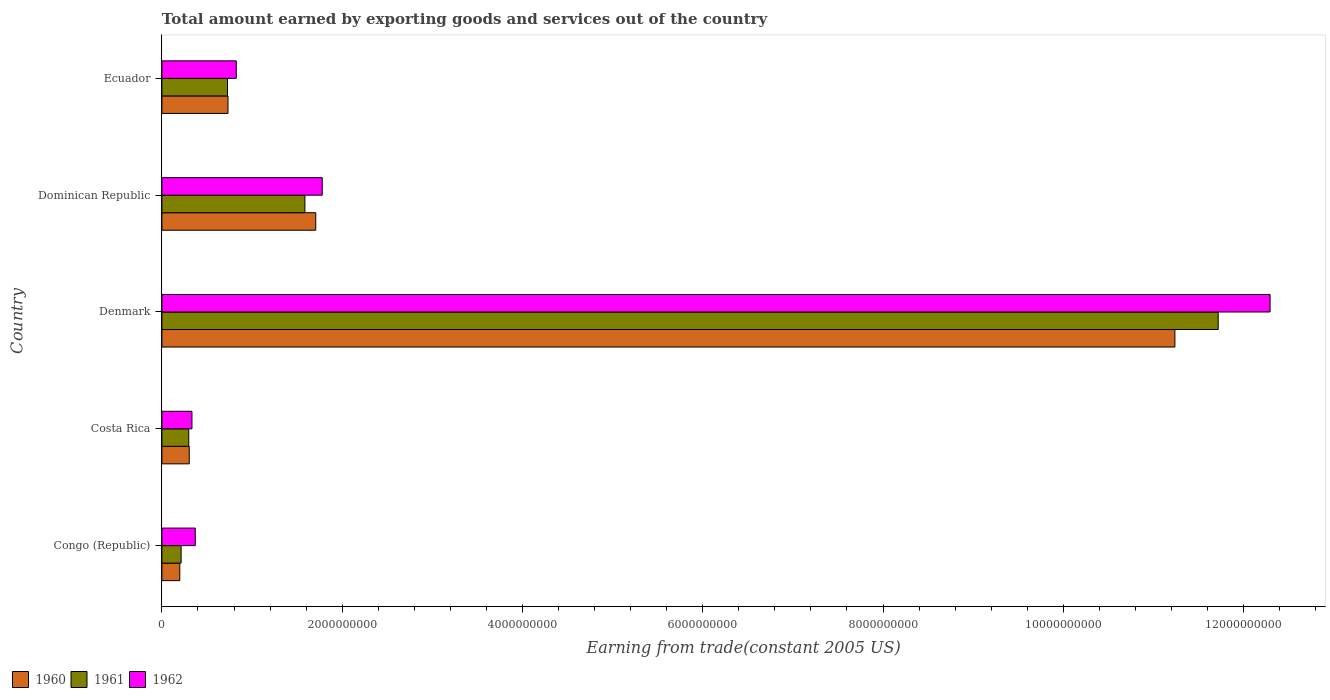How many groups of bars are there?
Provide a succinct answer. 5. What is the label of the 3rd group of bars from the top?
Ensure brevity in your answer.  Denmark. What is the total amount earned by exporting goods and services in 1961 in Denmark?
Give a very brief answer. 1.17e+1. Across all countries, what is the maximum total amount earned by exporting goods and services in 1960?
Offer a terse response. 1.12e+1. Across all countries, what is the minimum total amount earned by exporting goods and services in 1962?
Provide a succinct answer. 3.33e+08. In which country was the total amount earned by exporting goods and services in 1960 maximum?
Offer a very short reply. Denmark. In which country was the total amount earned by exporting goods and services in 1961 minimum?
Offer a terse response. Congo (Republic). What is the total total amount earned by exporting goods and services in 1962 in the graph?
Your answer should be very brief. 1.56e+1. What is the difference between the total amount earned by exporting goods and services in 1961 in Denmark and that in Dominican Republic?
Provide a short and direct response. 1.01e+1. What is the difference between the total amount earned by exporting goods and services in 1962 in Costa Rica and the total amount earned by exporting goods and services in 1960 in Dominican Republic?
Provide a short and direct response. -1.37e+09. What is the average total amount earned by exporting goods and services in 1962 per country?
Your answer should be very brief. 3.12e+09. What is the difference between the total amount earned by exporting goods and services in 1961 and total amount earned by exporting goods and services in 1962 in Congo (Republic)?
Provide a short and direct response. -1.57e+08. What is the ratio of the total amount earned by exporting goods and services in 1961 in Dominican Republic to that in Ecuador?
Your response must be concise. 2.18. Is the difference between the total amount earned by exporting goods and services in 1961 in Costa Rica and Dominican Republic greater than the difference between the total amount earned by exporting goods and services in 1962 in Costa Rica and Dominican Republic?
Offer a very short reply. Yes. What is the difference between the highest and the second highest total amount earned by exporting goods and services in 1960?
Provide a succinct answer. 9.53e+09. What is the difference between the highest and the lowest total amount earned by exporting goods and services in 1962?
Make the answer very short. 1.20e+1. In how many countries, is the total amount earned by exporting goods and services in 1962 greater than the average total amount earned by exporting goods and services in 1962 taken over all countries?
Offer a terse response. 1. Is the sum of the total amount earned by exporting goods and services in 1962 in Costa Rica and Denmark greater than the maximum total amount earned by exporting goods and services in 1961 across all countries?
Ensure brevity in your answer.  Yes. Is it the case that in every country, the sum of the total amount earned by exporting goods and services in 1962 and total amount earned by exporting goods and services in 1960 is greater than the total amount earned by exporting goods and services in 1961?
Keep it short and to the point. Yes. How many bars are there?
Your answer should be compact. 15. What is the difference between two consecutive major ticks on the X-axis?
Provide a succinct answer. 2.00e+09. Are the values on the major ticks of X-axis written in scientific E-notation?
Your response must be concise. No. Does the graph contain any zero values?
Ensure brevity in your answer.  No. How many legend labels are there?
Give a very brief answer. 3. How are the legend labels stacked?
Give a very brief answer. Horizontal. What is the title of the graph?
Give a very brief answer. Total amount earned by exporting goods and services out of the country. Does "1975" appear as one of the legend labels in the graph?
Ensure brevity in your answer.  No. What is the label or title of the X-axis?
Provide a succinct answer. Earning from trade(constant 2005 US). What is the Earning from trade(constant 2005 US) of 1960 in Congo (Republic)?
Offer a very short reply. 1.98e+08. What is the Earning from trade(constant 2005 US) in 1961 in Congo (Republic)?
Make the answer very short. 2.13e+08. What is the Earning from trade(constant 2005 US) in 1962 in Congo (Republic)?
Provide a succinct answer. 3.70e+08. What is the Earning from trade(constant 2005 US) of 1960 in Costa Rica?
Ensure brevity in your answer.  3.03e+08. What is the Earning from trade(constant 2005 US) in 1961 in Costa Rica?
Provide a short and direct response. 2.98e+08. What is the Earning from trade(constant 2005 US) of 1962 in Costa Rica?
Make the answer very short. 3.33e+08. What is the Earning from trade(constant 2005 US) in 1960 in Denmark?
Your answer should be compact. 1.12e+1. What is the Earning from trade(constant 2005 US) of 1961 in Denmark?
Provide a short and direct response. 1.17e+1. What is the Earning from trade(constant 2005 US) in 1962 in Denmark?
Ensure brevity in your answer.  1.23e+1. What is the Earning from trade(constant 2005 US) of 1960 in Dominican Republic?
Offer a terse response. 1.71e+09. What is the Earning from trade(constant 2005 US) in 1961 in Dominican Republic?
Your response must be concise. 1.59e+09. What is the Earning from trade(constant 2005 US) of 1962 in Dominican Republic?
Keep it short and to the point. 1.78e+09. What is the Earning from trade(constant 2005 US) of 1960 in Ecuador?
Your answer should be compact. 7.33e+08. What is the Earning from trade(constant 2005 US) of 1961 in Ecuador?
Make the answer very short. 7.28e+08. What is the Earning from trade(constant 2005 US) of 1962 in Ecuador?
Keep it short and to the point. 8.25e+08. Across all countries, what is the maximum Earning from trade(constant 2005 US) of 1960?
Provide a short and direct response. 1.12e+1. Across all countries, what is the maximum Earning from trade(constant 2005 US) in 1961?
Your answer should be very brief. 1.17e+1. Across all countries, what is the maximum Earning from trade(constant 2005 US) of 1962?
Offer a terse response. 1.23e+1. Across all countries, what is the minimum Earning from trade(constant 2005 US) of 1960?
Ensure brevity in your answer.  1.98e+08. Across all countries, what is the minimum Earning from trade(constant 2005 US) in 1961?
Provide a succinct answer. 2.13e+08. Across all countries, what is the minimum Earning from trade(constant 2005 US) of 1962?
Your answer should be compact. 3.33e+08. What is the total Earning from trade(constant 2005 US) of 1960 in the graph?
Provide a short and direct response. 1.42e+1. What is the total Earning from trade(constant 2005 US) of 1961 in the graph?
Keep it short and to the point. 1.45e+1. What is the total Earning from trade(constant 2005 US) of 1962 in the graph?
Provide a short and direct response. 1.56e+1. What is the difference between the Earning from trade(constant 2005 US) of 1960 in Congo (Republic) and that in Costa Rica?
Keep it short and to the point. -1.05e+08. What is the difference between the Earning from trade(constant 2005 US) of 1961 in Congo (Republic) and that in Costa Rica?
Your response must be concise. -8.47e+07. What is the difference between the Earning from trade(constant 2005 US) in 1962 in Congo (Republic) and that in Costa Rica?
Your answer should be very brief. 3.67e+07. What is the difference between the Earning from trade(constant 2005 US) of 1960 in Congo (Republic) and that in Denmark?
Keep it short and to the point. -1.10e+1. What is the difference between the Earning from trade(constant 2005 US) of 1961 in Congo (Republic) and that in Denmark?
Your answer should be very brief. -1.15e+1. What is the difference between the Earning from trade(constant 2005 US) of 1962 in Congo (Republic) and that in Denmark?
Provide a short and direct response. -1.19e+1. What is the difference between the Earning from trade(constant 2005 US) of 1960 in Congo (Republic) and that in Dominican Republic?
Ensure brevity in your answer.  -1.51e+09. What is the difference between the Earning from trade(constant 2005 US) of 1961 in Congo (Republic) and that in Dominican Republic?
Your answer should be very brief. -1.37e+09. What is the difference between the Earning from trade(constant 2005 US) in 1962 in Congo (Republic) and that in Dominican Republic?
Your answer should be compact. -1.41e+09. What is the difference between the Earning from trade(constant 2005 US) of 1960 in Congo (Republic) and that in Ecuador?
Offer a terse response. -5.35e+08. What is the difference between the Earning from trade(constant 2005 US) of 1961 in Congo (Republic) and that in Ecuador?
Provide a short and direct response. -5.15e+08. What is the difference between the Earning from trade(constant 2005 US) of 1962 in Congo (Republic) and that in Ecuador?
Offer a terse response. -4.55e+08. What is the difference between the Earning from trade(constant 2005 US) of 1960 in Costa Rica and that in Denmark?
Your answer should be compact. -1.09e+1. What is the difference between the Earning from trade(constant 2005 US) of 1961 in Costa Rica and that in Denmark?
Keep it short and to the point. -1.14e+1. What is the difference between the Earning from trade(constant 2005 US) of 1962 in Costa Rica and that in Denmark?
Provide a succinct answer. -1.20e+1. What is the difference between the Earning from trade(constant 2005 US) in 1960 in Costa Rica and that in Dominican Republic?
Your answer should be compact. -1.40e+09. What is the difference between the Earning from trade(constant 2005 US) of 1961 in Costa Rica and that in Dominican Republic?
Give a very brief answer. -1.29e+09. What is the difference between the Earning from trade(constant 2005 US) of 1962 in Costa Rica and that in Dominican Republic?
Keep it short and to the point. -1.45e+09. What is the difference between the Earning from trade(constant 2005 US) of 1960 in Costa Rica and that in Ecuador?
Give a very brief answer. -4.30e+08. What is the difference between the Earning from trade(constant 2005 US) in 1961 in Costa Rica and that in Ecuador?
Provide a succinct answer. -4.30e+08. What is the difference between the Earning from trade(constant 2005 US) of 1962 in Costa Rica and that in Ecuador?
Provide a short and direct response. -4.92e+08. What is the difference between the Earning from trade(constant 2005 US) of 1960 in Denmark and that in Dominican Republic?
Your answer should be compact. 9.53e+09. What is the difference between the Earning from trade(constant 2005 US) in 1961 in Denmark and that in Dominican Republic?
Provide a short and direct response. 1.01e+1. What is the difference between the Earning from trade(constant 2005 US) of 1962 in Denmark and that in Dominican Republic?
Provide a succinct answer. 1.05e+1. What is the difference between the Earning from trade(constant 2005 US) in 1960 in Denmark and that in Ecuador?
Provide a short and direct response. 1.05e+1. What is the difference between the Earning from trade(constant 2005 US) of 1961 in Denmark and that in Ecuador?
Offer a terse response. 1.10e+1. What is the difference between the Earning from trade(constant 2005 US) in 1962 in Denmark and that in Ecuador?
Your response must be concise. 1.15e+1. What is the difference between the Earning from trade(constant 2005 US) in 1960 in Dominican Republic and that in Ecuador?
Offer a very short reply. 9.74e+08. What is the difference between the Earning from trade(constant 2005 US) in 1961 in Dominican Republic and that in Ecuador?
Ensure brevity in your answer.  8.59e+08. What is the difference between the Earning from trade(constant 2005 US) in 1962 in Dominican Republic and that in Ecuador?
Ensure brevity in your answer.  9.54e+08. What is the difference between the Earning from trade(constant 2005 US) in 1960 in Congo (Republic) and the Earning from trade(constant 2005 US) in 1961 in Costa Rica?
Provide a short and direct response. -9.96e+07. What is the difference between the Earning from trade(constant 2005 US) in 1960 in Congo (Republic) and the Earning from trade(constant 2005 US) in 1962 in Costa Rica?
Offer a terse response. -1.35e+08. What is the difference between the Earning from trade(constant 2005 US) in 1961 in Congo (Republic) and the Earning from trade(constant 2005 US) in 1962 in Costa Rica?
Provide a succinct answer. -1.20e+08. What is the difference between the Earning from trade(constant 2005 US) of 1960 in Congo (Republic) and the Earning from trade(constant 2005 US) of 1961 in Denmark?
Your response must be concise. -1.15e+1. What is the difference between the Earning from trade(constant 2005 US) in 1960 in Congo (Republic) and the Earning from trade(constant 2005 US) in 1962 in Denmark?
Ensure brevity in your answer.  -1.21e+1. What is the difference between the Earning from trade(constant 2005 US) in 1961 in Congo (Republic) and the Earning from trade(constant 2005 US) in 1962 in Denmark?
Give a very brief answer. -1.21e+1. What is the difference between the Earning from trade(constant 2005 US) in 1960 in Congo (Republic) and the Earning from trade(constant 2005 US) in 1961 in Dominican Republic?
Your response must be concise. -1.39e+09. What is the difference between the Earning from trade(constant 2005 US) of 1960 in Congo (Republic) and the Earning from trade(constant 2005 US) of 1962 in Dominican Republic?
Your answer should be very brief. -1.58e+09. What is the difference between the Earning from trade(constant 2005 US) in 1961 in Congo (Republic) and the Earning from trade(constant 2005 US) in 1962 in Dominican Republic?
Provide a succinct answer. -1.57e+09. What is the difference between the Earning from trade(constant 2005 US) of 1960 in Congo (Republic) and the Earning from trade(constant 2005 US) of 1961 in Ecuador?
Your answer should be compact. -5.29e+08. What is the difference between the Earning from trade(constant 2005 US) of 1960 in Congo (Republic) and the Earning from trade(constant 2005 US) of 1962 in Ecuador?
Offer a terse response. -6.27e+08. What is the difference between the Earning from trade(constant 2005 US) of 1961 in Congo (Republic) and the Earning from trade(constant 2005 US) of 1962 in Ecuador?
Keep it short and to the point. -6.12e+08. What is the difference between the Earning from trade(constant 2005 US) of 1960 in Costa Rica and the Earning from trade(constant 2005 US) of 1961 in Denmark?
Make the answer very short. -1.14e+1. What is the difference between the Earning from trade(constant 2005 US) of 1960 in Costa Rica and the Earning from trade(constant 2005 US) of 1962 in Denmark?
Provide a succinct answer. -1.20e+1. What is the difference between the Earning from trade(constant 2005 US) of 1961 in Costa Rica and the Earning from trade(constant 2005 US) of 1962 in Denmark?
Offer a terse response. -1.20e+1. What is the difference between the Earning from trade(constant 2005 US) of 1960 in Costa Rica and the Earning from trade(constant 2005 US) of 1961 in Dominican Republic?
Your answer should be compact. -1.28e+09. What is the difference between the Earning from trade(constant 2005 US) in 1960 in Costa Rica and the Earning from trade(constant 2005 US) in 1962 in Dominican Republic?
Your response must be concise. -1.48e+09. What is the difference between the Earning from trade(constant 2005 US) in 1961 in Costa Rica and the Earning from trade(constant 2005 US) in 1962 in Dominican Republic?
Provide a succinct answer. -1.48e+09. What is the difference between the Earning from trade(constant 2005 US) of 1960 in Costa Rica and the Earning from trade(constant 2005 US) of 1961 in Ecuador?
Keep it short and to the point. -4.24e+08. What is the difference between the Earning from trade(constant 2005 US) of 1960 in Costa Rica and the Earning from trade(constant 2005 US) of 1962 in Ecuador?
Keep it short and to the point. -5.22e+08. What is the difference between the Earning from trade(constant 2005 US) in 1961 in Costa Rica and the Earning from trade(constant 2005 US) in 1962 in Ecuador?
Offer a very short reply. -5.27e+08. What is the difference between the Earning from trade(constant 2005 US) in 1960 in Denmark and the Earning from trade(constant 2005 US) in 1961 in Dominican Republic?
Offer a very short reply. 9.65e+09. What is the difference between the Earning from trade(constant 2005 US) in 1960 in Denmark and the Earning from trade(constant 2005 US) in 1962 in Dominican Republic?
Provide a succinct answer. 9.46e+09. What is the difference between the Earning from trade(constant 2005 US) in 1961 in Denmark and the Earning from trade(constant 2005 US) in 1962 in Dominican Republic?
Keep it short and to the point. 9.94e+09. What is the difference between the Earning from trade(constant 2005 US) of 1960 in Denmark and the Earning from trade(constant 2005 US) of 1961 in Ecuador?
Offer a terse response. 1.05e+1. What is the difference between the Earning from trade(constant 2005 US) of 1960 in Denmark and the Earning from trade(constant 2005 US) of 1962 in Ecuador?
Your answer should be very brief. 1.04e+1. What is the difference between the Earning from trade(constant 2005 US) in 1961 in Denmark and the Earning from trade(constant 2005 US) in 1962 in Ecuador?
Keep it short and to the point. 1.09e+1. What is the difference between the Earning from trade(constant 2005 US) in 1960 in Dominican Republic and the Earning from trade(constant 2005 US) in 1961 in Ecuador?
Give a very brief answer. 9.79e+08. What is the difference between the Earning from trade(constant 2005 US) of 1960 in Dominican Republic and the Earning from trade(constant 2005 US) of 1962 in Ecuador?
Give a very brief answer. 8.81e+08. What is the difference between the Earning from trade(constant 2005 US) in 1961 in Dominican Republic and the Earning from trade(constant 2005 US) in 1962 in Ecuador?
Provide a succinct answer. 7.61e+08. What is the average Earning from trade(constant 2005 US) in 1960 per country?
Provide a short and direct response. 2.84e+09. What is the average Earning from trade(constant 2005 US) of 1961 per country?
Your response must be concise. 2.91e+09. What is the average Earning from trade(constant 2005 US) of 1962 per country?
Provide a succinct answer. 3.12e+09. What is the difference between the Earning from trade(constant 2005 US) of 1960 and Earning from trade(constant 2005 US) of 1961 in Congo (Republic)?
Offer a terse response. -1.49e+07. What is the difference between the Earning from trade(constant 2005 US) in 1960 and Earning from trade(constant 2005 US) in 1962 in Congo (Republic)?
Offer a terse response. -1.72e+08. What is the difference between the Earning from trade(constant 2005 US) in 1961 and Earning from trade(constant 2005 US) in 1962 in Congo (Republic)?
Give a very brief answer. -1.57e+08. What is the difference between the Earning from trade(constant 2005 US) in 1960 and Earning from trade(constant 2005 US) in 1961 in Costa Rica?
Make the answer very short. 5.57e+06. What is the difference between the Earning from trade(constant 2005 US) of 1960 and Earning from trade(constant 2005 US) of 1962 in Costa Rica?
Keep it short and to the point. -3.00e+07. What is the difference between the Earning from trade(constant 2005 US) of 1961 and Earning from trade(constant 2005 US) of 1962 in Costa Rica?
Your response must be concise. -3.56e+07. What is the difference between the Earning from trade(constant 2005 US) of 1960 and Earning from trade(constant 2005 US) of 1961 in Denmark?
Offer a terse response. -4.81e+08. What is the difference between the Earning from trade(constant 2005 US) in 1960 and Earning from trade(constant 2005 US) in 1962 in Denmark?
Your answer should be compact. -1.06e+09. What is the difference between the Earning from trade(constant 2005 US) of 1961 and Earning from trade(constant 2005 US) of 1962 in Denmark?
Keep it short and to the point. -5.76e+08. What is the difference between the Earning from trade(constant 2005 US) in 1960 and Earning from trade(constant 2005 US) in 1961 in Dominican Republic?
Provide a succinct answer. 1.20e+08. What is the difference between the Earning from trade(constant 2005 US) of 1960 and Earning from trade(constant 2005 US) of 1962 in Dominican Republic?
Provide a short and direct response. -7.23e+07. What is the difference between the Earning from trade(constant 2005 US) of 1961 and Earning from trade(constant 2005 US) of 1962 in Dominican Republic?
Make the answer very short. -1.92e+08. What is the difference between the Earning from trade(constant 2005 US) of 1960 and Earning from trade(constant 2005 US) of 1961 in Ecuador?
Provide a succinct answer. 5.42e+06. What is the difference between the Earning from trade(constant 2005 US) in 1960 and Earning from trade(constant 2005 US) in 1962 in Ecuador?
Make the answer very short. -9.21e+07. What is the difference between the Earning from trade(constant 2005 US) of 1961 and Earning from trade(constant 2005 US) of 1962 in Ecuador?
Provide a short and direct response. -9.75e+07. What is the ratio of the Earning from trade(constant 2005 US) of 1960 in Congo (Republic) to that in Costa Rica?
Keep it short and to the point. 0.65. What is the ratio of the Earning from trade(constant 2005 US) in 1961 in Congo (Republic) to that in Costa Rica?
Your answer should be compact. 0.72. What is the ratio of the Earning from trade(constant 2005 US) in 1962 in Congo (Republic) to that in Costa Rica?
Provide a short and direct response. 1.11. What is the ratio of the Earning from trade(constant 2005 US) in 1960 in Congo (Republic) to that in Denmark?
Give a very brief answer. 0.02. What is the ratio of the Earning from trade(constant 2005 US) of 1961 in Congo (Republic) to that in Denmark?
Your answer should be very brief. 0.02. What is the ratio of the Earning from trade(constant 2005 US) in 1962 in Congo (Republic) to that in Denmark?
Give a very brief answer. 0.03. What is the ratio of the Earning from trade(constant 2005 US) in 1960 in Congo (Republic) to that in Dominican Republic?
Provide a succinct answer. 0.12. What is the ratio of the Earning from trade(constant 2005 US) of 1961 in Congo (Republic) to that in Dominican Republic?
Ensure brevity in your answer.  0.13. What is the ratio of the Earning from trade(constant 2005 US) of 1962 in Congo (Republic) to that in Dominican Republic?
Provide a short and direct response. 0.21. What is the ratio of the Earning from trade(constant 2005 US) of 1960 in Congo (Republic) to that in Ecuador?
Your answer should be very brief. 0.27. What is the ratio of the Earning from trade(constant 2005 US) of 1961 in Congo (Republic) to that in Ecuador?
Ensure brevity in your answer.  0.29. What is the ratio of the Earning from trade(constant 2005 US) of 1962 in Congo (Republic) to that in Ecuador?
Make the answer very short. 0.45. What is the ratio of the Earning from trade(constant 2005 US) of 1960 in Costa Rica to that in Denmark?
Your answer should be compact. 0.03. What is the ratio of the Earning from trade(constant 2005 US) in 1961 in Costa Rica to that in Denmark?
Make the answer very short. 0.03. What is the ratio of the Earning from trade(constant 2005 US) of 1962 in Costa Rica to that in Denmark?
Provide a succinct answer. 0.03. What is the ratio of the Earning from trade(constant 2005 US) in 1960 in Costa Rica to that in Dominican Republic?
Your answer should be very brief. 0.18. What is the ratio of the Earning from trade(constant 2005 US) of 1961 in Costa Rica to that in Dominican Republic?
Provide a succinct answer. 0.19. What is the ratio of the Earning from trade(constant 2005 US) in 1962 in Costa Rica to that in Dominican Republic?
Offer a terse response. 0.19. What is the ratio of the Earning from trade(constant 2005 US) of 1960 in Costa Rica to that in Ecuador?
Your answer should be very brief. 0.41. What is the ratio of the Earning from trade(constant 2005 US) in 1961 in Costa Rica to that in Ecuador?
Ensure brevity in your answer.  0.41. What is the ratio of the Earning from trade(constant 2005 US) in 1962 in Costa Rica to that in Ecuador?
Ensure brevity in your answer.  0.4. What is the ratio of the Earning from trade(constant 2005 US) of 1960 in Denmark to that in Dominican Republic?
Your answer should be very brief. 6.59. What is the ratio of the Earning from trade(constant 2005 US) of 1961 in Denmark to that in Dominican Republic?
Offer a very short reply. 7.39. What is the ratio of the Earning from trade(constant 2005 US) in 1962 in Denmark to that in Dominican Republic?
Offer a very short reply. 6.91. What is the ratio of the Earning from trade(constant 2005 US) of 1960 in Denmark to that in Ecuador?
Offer a terse response. 15.33. What is the ratio of the Earning from trade(constant 2005 US) in 1961 in Denmark to that in Ecuador?
Your answer should be very brief. 16.1. What is the ratio of the Earning from trade(constant 2005 US) in 1962 in Denmark to that in Ecuador?
Offer a very short reply. 14.9. What is the ratio of the Earning from trade(constant 2005 US) of 1960 in Dominican Republic to that in Ecuador?
Your response must be concise. 2.33. What is the ratio of the Earning from trade(constant 2005 US) in 1961 in Dominican Republic to that in Ecuador?
Make the answer very short. 2.18. What is the ratio of the Earning from trade(constant 2005 US) in 1962 in Dominican Republic to that in Ecuador?
Keep it short and to the point. 2.16. What is the difference between the highest and the second highest Earning from trade(constant 2005 US) in 1960?
Make the answer very short. 9.53e+09. What is the difference between the highest and the second highest Earning from trade(constant 2005 US) in 1961?
Your response must be concise. 1.01e+1. What is the difference between the highest and the second highest Earning from trade(constant 2005 US) of 1962?
Provide a short and direct response. 1.05e+1. What is the difference between the highest and the lowest Earning from trade(constant 2005 US) in 1960?
Your answer should be very brief. 1.10e+1. What is the difference between the highest and the lowest Earning from trade(constant 2005 US) in 1961?
Offer a very short reply. 1.15e+1. What is the difference between the highest and the lowest Earning from trade(constant 2005 US) of 1962?
Provide a succinct answer. 1.20e+1. 